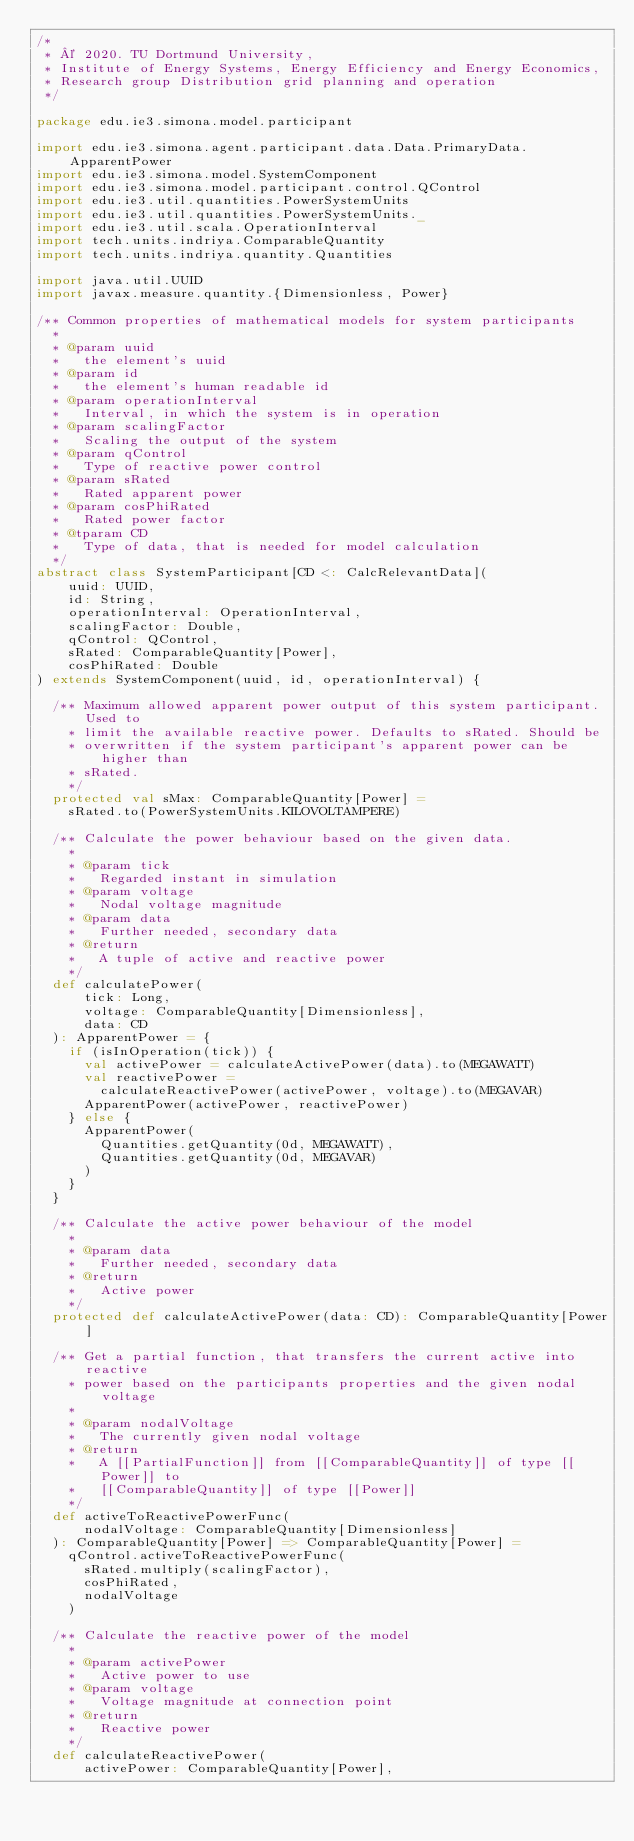Convert code to text. <code><loc_0><loc_0><loc_500><loc_500><_Scala_>/*
 * © 2020. TU Dortmund University,
 * Institute of Energy Systems, Energy Efficiency and Energy Economics,
 * Research group Distribution grid planning and operation
 */

package edu.ie3.simona.model.participant

import edu.ie3.simona.agent.participant.data.Data.PrimaryData.ApparentPower
import edu.ie3.simona.model.SystemComponent
import edu.ie3.simona.model.participant.control.QControl
import edu.ie3.util.quantities.PowerSystemUnits
import edu.ie3.util.quantities.PowerSystemUnits._
import edu.ie3.util.scala.OperationInterval
import tech.units.indriya.ComparableQuantity
import tech.units.indriya.quantity.Quantities

import java.util.UUID
import javax.measure.quantity.{Dimensionless, Power}

/** Common properties of mathematical models for system participants
  *
  * @param uuid
  *   the element's uuid
  * @param id
  *   the element's human readable id
  * @param operationInterval
  *   Interval, in which the system is in operation
  * @param scalingFactor
  *   Scaling the output of the system
  * @param qControl
  *   Type of reactive power control
  * @param sRated
  *   Rated apparent power
  * @param cosPhiRated
  *   Rated power factor
  * @tparam CD
  *   Type of data, that is needed for model calculation
  */
abstract class SystemParticipant[CD <: CalcRelevantData](
    uuid: UUID,
    id: String,
    operationInterval: OperationInterval,
    scalingFactor: Double,
    qControl: QControl,
    sRated: ComparableQuantity[Power],
    cosPhiRated: Double
) extends SystemComponent(uuid, id, operationInterval) {

  /** Maximum allowed apparent power output of this system participant. Used to
    * limit the available reactive power. Defaults to sRated. Should be
    * overwritten if the system participant's apparent power can be higher than
    * sRated.
    */
  protected val sMax: ComparableQuantity[Power] =
    sRated.to(PowerSystemUnits.KILOVOLTAMPERE)

  /** Calculate the power behaviour based on the given data.
    *
    * @param tick
    *   Regarded instant in simulation
    * @param voltage
    *   Nodal voltage magnitude
    * @param data
    *   Further needed, secondary data
    * @return
    *   A tuple of active and reactive power
    */
  def calculatePower(
      tick: Long,
      voltage: ComparableQuantity[Dimensionless],
      data: CD
  ): ApparentPower = {
    if (isInOperation(tick)) {
      val activePower = calculateActivePower(data).to(MEGAWATT)
      val reactivePower =
        calculateReactivePower(activePower, voltage).to(MEGAVAR)
      ApparentPower(activePower, reactivePower)
    } else {
      ApparentPower(
        Quantities.getQuantity(0d, MEGAWATT),
        Quantities.getQuantity(0d, MEGAVAR)
      )
    }
  }

  /** Calculate the active power behaviour of the model
    *
    * @param data
    *   Further needed, secondary data
    * @return
    *   Active power
    */
  protected def calculateActivePower(data: CD): ComparableQuantity[Power]

  /** Get a partial function, that transfers the current active into reactive
    * power based on the participants properties and the given nodal voltage
    *
    * @param nodalVoltage
    *   The currently given nodal voltage
    * @return
    *   A [[PartialFunction]] from [[ComparableQuantity]] of type [[Power]] to
    *   [[ComparableQuantity]] of type [[Power]]
    */
  def activeToReactivePowerFunc(
      nodalVoltage: ComparableQuantity[Dimensionless]
  ): ComparableQuantity[Power] => ComparableQuantity[Power] =
    qControl.activeToReactivePowerFunc(
      sRated.multiply(scalingFactor),
      cosPhiRated,
      nodalVoltage
    )

  /** Calculate the reactive power of the model
    *
    * @param activePower
    *   Active power to use
    * @param voltage
    *   Voltage magnitude at connection point
    * @return
    *   Reactive power
    */
  def calculateReactivePower(
      activePower: ComparableQuantity[Power],</code> 